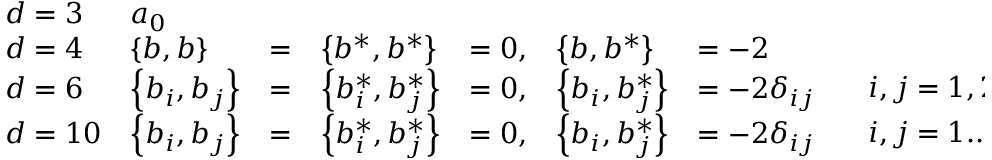Convert formula to latex. <formula><loc_0><loc_0><loc_500><loc_500>\begin{array} { l l l l l l l l } { d = 3 } & { { a _ { 0 } } } & { { \begin{array} { l } \end{array} } } \\ { d = 4 } & { { \left \{ b , b \right \} } } & { = } & { { \left \{ b ^ { * } , b ^ { * } \right \} } } & { = 0 , } & { { \left \{ b , b ^ { * } \right \} } } & { = - 2 } & { { \begin{array} { l } \end{array} } } \\ { d = 6 } & { { \left \{ b _ { i } , b _ { j } \right \} } } & { = } & { { \left \{ b _ { i } ^ { * } , b _ { j } ^ { * } \right \} } } & { = 0 , } & { { \left \{ b _ { i } , b _ { j } ^ { * } \right \} } } & { { = - 2 \delta _ { i j } } } & { { \begin{array} { l } { \ i , j = 1 , 2 } \end{array} } } \\ { d = 1 0 } & { { \left \{ b _ { i } , b _ { j } \right \} } } & { = } & { { \left \{ b _ { i } ^ { * } , b _ { j } ^ { * } \right \} } } & { = 0 , } & { { \left \{ b _ { i } , b _ { j } ^ { * } \right \} } } & { { = - 2 \delta _ { i j } } } & { { \begin{array} { l } { \ i , j = 1 . . 4 } \end{array} } } \end{array}</formula> 